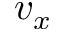<formula> <loc_0><loc_0><loc_500><loc_500>v _ { x }</formula> 